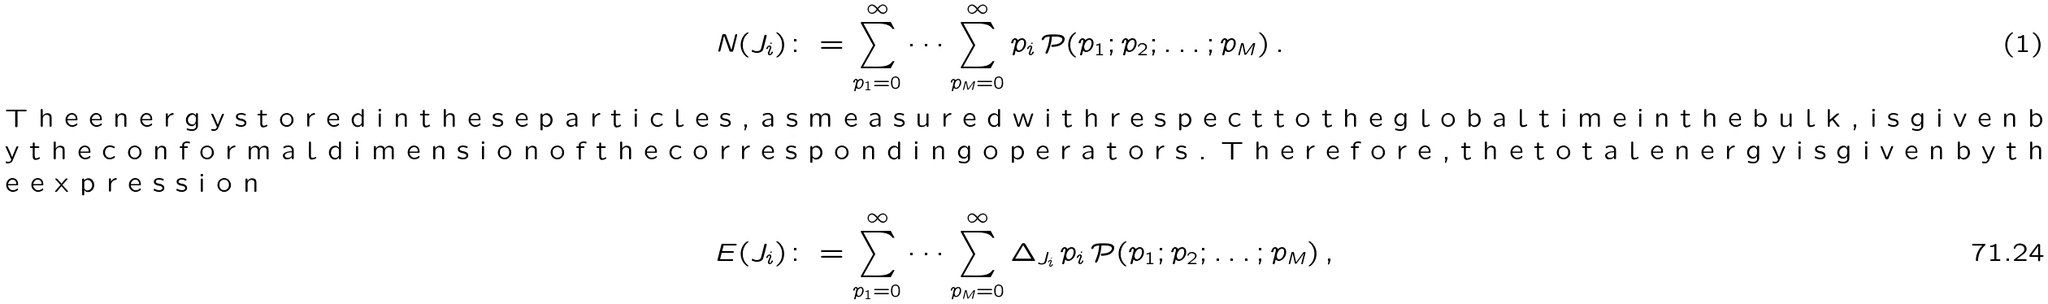Convert formula to latex. <formula><loc_0><loc_0><loc_500><loc_500>N ( J _ { i } ) & \colon = \sum _ { p _ { 1 } = 0 } ^ { \infty } \cdots \sum _ { p _ { M } = 0 } ^ { \infty } p _ { i } \, { \mathcal { P } } ( p _ { 1 } ; p _ { 2 } ; \dots ; p _ { M } ) \, . \intertext { T h e e n e r g y s t o r e d i n t h e s e p a r t i c l e s , a s m e a s u r e d w i t h r e s p e c t t o t h e g l o b a l t i m e i n t h e b u l k , i s g i v e n b y t h e c o n f o r m a l d i m e n s i o n o f t h e c o r r e s p o n d i n g o p e r a t o r s . T h e r e f o r e , t h e t o t a l e n e r g y i s g i v e n b y t h e e x p r e s s i o n } E ( J _ { i } ) & \colon = \sum _ { p _ { 1 } = 0 } ^ { \infty } \cdots \sum _ { p _ { M } = 0 } ^ { \infty } \Delta _ { J _ { i } } \, p _ { i } \, { \mathcal { P } } ( p _ { 1 } ; p _ { 2 } ; \dots ; p _ { M } ) \, ,</formula> 